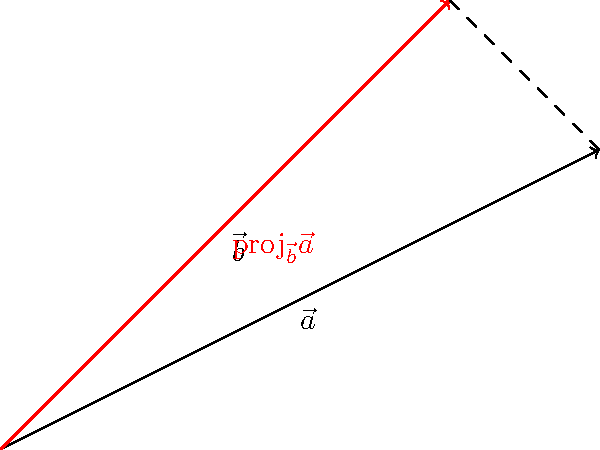In the diagram, vector $\vec{a} = 4\hat{i} + 2\hat{j}$ and vector $\vec{b} = 3\hat{i} + 3\hat{j}$. Calculate the magnitude of the projection of $\vec{a}$ onto $\vec{b}$. How might this concept be applied in optimizing the efficiency of wind turbines? To solve this problem, we'll follow these steps:

1) The formula for the projection of $\vec{a}$ onto $\vec{b}$ is:

   $$\text{proj}_{\vec{b}}\vec{a} = \frac{\vec{a} \cdot \vec{b}}{\|\vec{b}\|^2} \vec{b}$$

2) First, calculate the dot product $\vec{a} \cdot \vec{b}$:
   $$\vec{a} \cdot \vec{b} = (4)(3) + (2)(3) = 12 + 6 = 18$$

3) Calculate $\|\vec{b}\|^2$:
   $$\|\vec{b}\|^2 = 3^2 + 3^2 = 18$$

4) Now, we can find the scalar projection:
   $$\frac{\vec{a} \cdot \vec{b}}{\|\vec{b}\|^2} = \frac{18}{18} = 1$$

5) The vector projection is:
   $$\text{proj}_{\vec{b}}\vec{a} = 1(3\hat{i} + 3\hat{j}) = 3\hat{i} + 3\hat{j}$$

6) The magnitude of this projection is:
   $$\|\text{proj}_{\vec{b}}\vec{a}\| = \sqrt{3^2 + 3^2} = \sqrt{18} = 3\sqrt{2}$$

Application to wind turbines:
Vector projections are crucial in optimizing wind turbine efficiency. The power output of a wind turbine depends on the component of wind velocity perpendicular to the plane of rotation of the turbine blades. This is essentially the projection of the wind velocity vector onto the normal vector of the turbine plane. By using vector projections, engineers can calculate the effective wind speed for power generation, helping to optimize turbine design and placement for maximum energy capture.
Answer: $3\sqrt{2}$ 